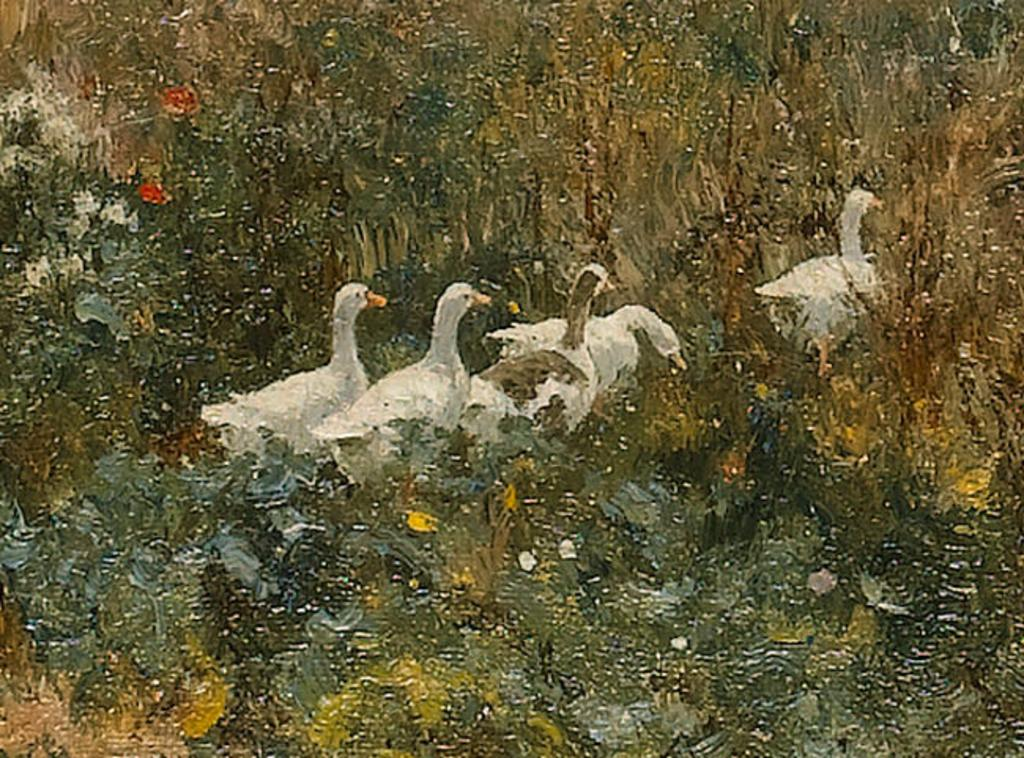What animals can be seen in the image? There are ducks in the image. What are the ducks doing in the image? The ducks are walking on the ground in the image. What else can be seen on the ground in the image? There are plants on the ground in the image. What type of artwork is the image? The image appears to be a painting. What type of business is being conducted in the image? There is no indication of any business activity in the image, as it features ducks walking on the ground and plants. 